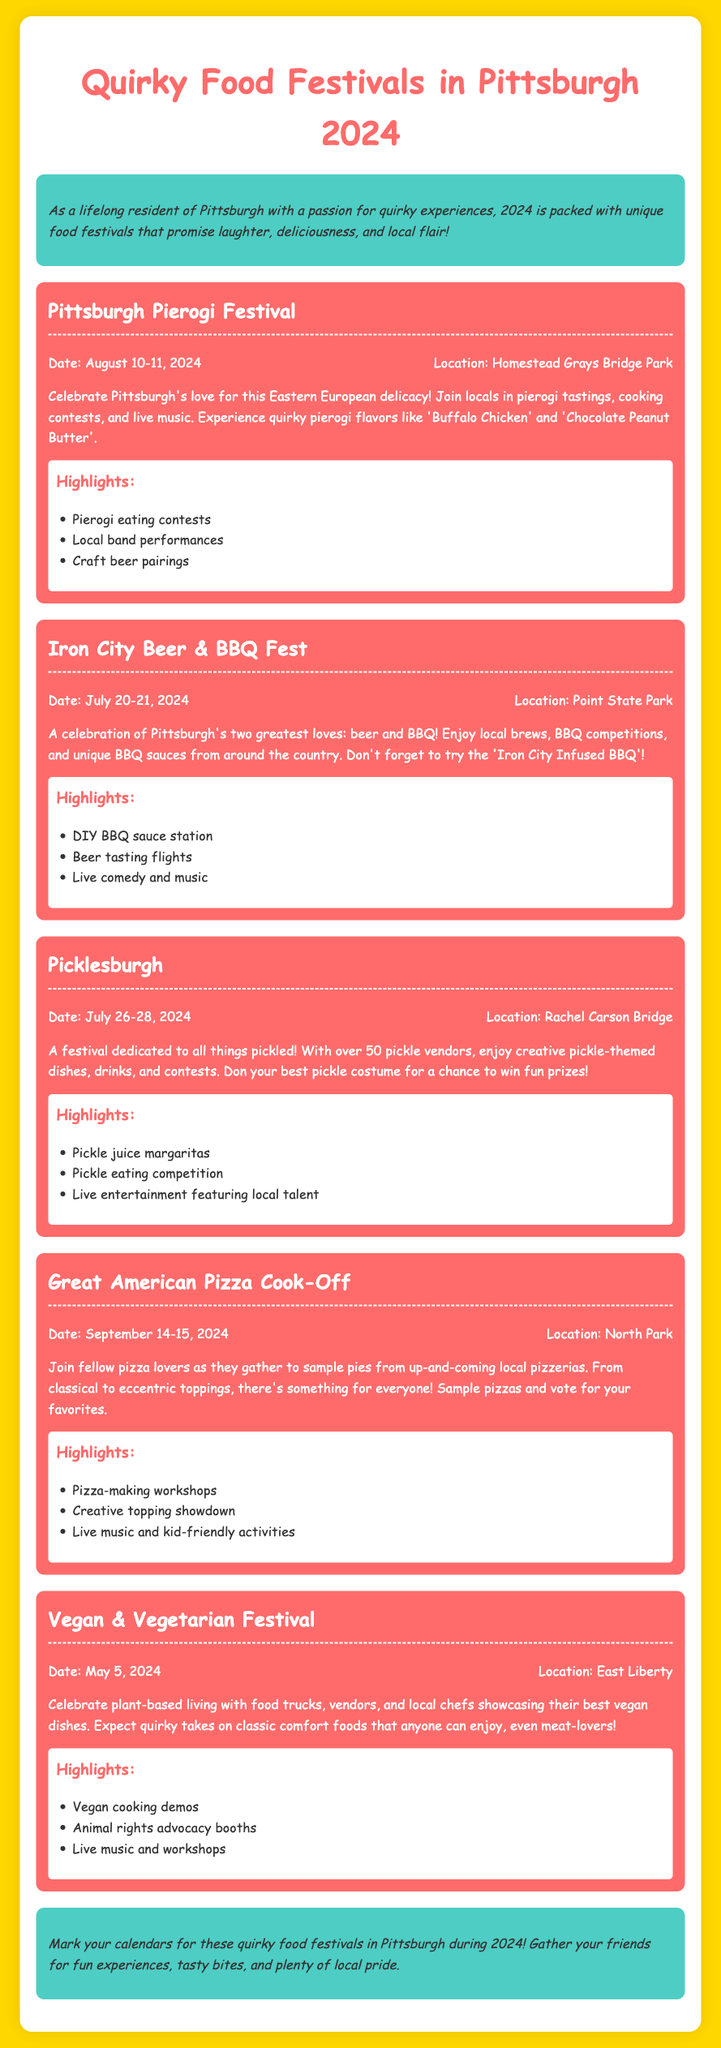What is the date of the Pittsburgh Pierogi Festival? The date of the Pittsburgh Pierogi Festival is mentioned as August 10-11, 2024.
Answer: August 10-11, 2024 Where will the Iron City Beer & BBQ Fest be held? The location of the Iron City Beer & BBQ Fest is specified as Point State Park.
Answer: Point State Park What is one highlight of the Picklesburgh festival? One of the highlights listed for the Picklesburgh festival includes the pickle juice margaritas.
Answer: Pickle juice margaritas How many pickle vendors will be at the Picklesburgh festival? The document states that there will be over 50 pickle vendors at the Picklesburgh festival.
Answer: Over 50 Which food festival takes place in May? The festival that takes place in May is the Vegan & Vegetarian Festival.
Answer: Vegan & Vegetarian Festival What unique BBQ item is mentioned at the Iron City Beer & BBQ Fest? The unique BBQ item mentioned is the 'Iron City Infused BBQ'.
Answer: Iron City Infused BBQ When is the Great American Pizza Cook-Off scheduled? The Great American Pizza Cook-Off is scheduled for September 14-15, 2024.
Answer: September 14-15, 2024 What type of music is featured at the Vegan & Vegetarian Festival? The event will feature live music as mentioned in the highlights for the Vegan & Vegetarian Festival.
Answer: Live music What is the main theme of the Picklesburgh festival? The main theme of the Picklesburgh festival is dedicated to all things pickled.
Answer: All things pickled 